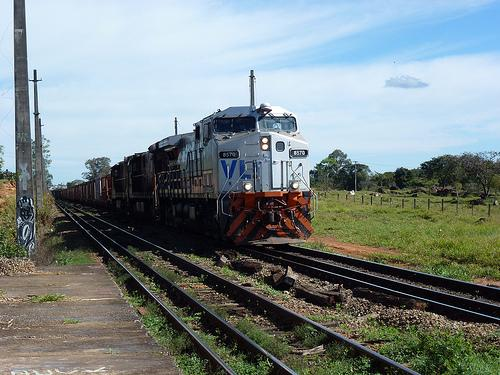Describe the primary object in the image and its colors. The primary object is a train, with black and orange stripes on the front, and a white front car. Describe the fencing in the field. There is wood and wire fencing in the grassy field. What are the colors of the cloud in the sky? The cloud in the sky is small and gray. What is the state of the wooden train platform? The wooden train platform has weeds growing on it. What can you observe on the electricity pole? Graffiti is painted on the electricity pole. What type of terrain surrounds the double train tracks? The double train tracks are surrounded by grass and gravel. What type of environment is the cargo train passing through and describe its front end. The cargo train is passing through a rural area and its front end has black and orange stripes. Count the number of lines of the track. There are 3 lines of the track. What type of train is depicted in the image? This is a freight train passing through a rural area. Identify the graffitied object in the image. There is graffiti written on a telephone pole. 